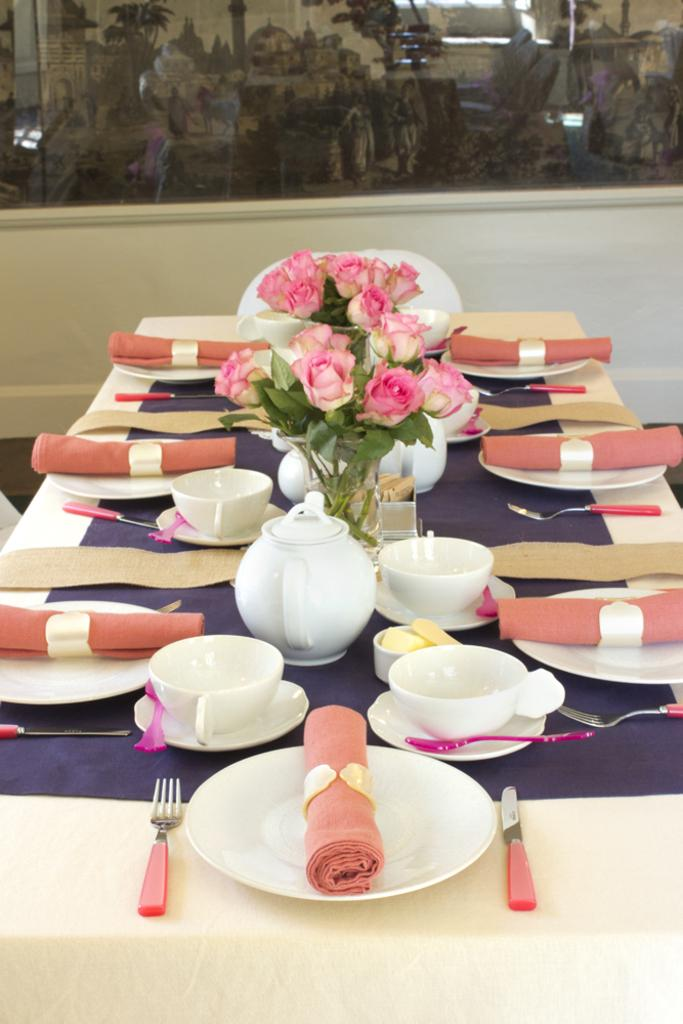What piece of furniture is present in the image? There is a table in the image. What is placed on the table? There is a plate, forks, a cup, a saucer, a bowl, a teapot, and a vase with flowers on the table. What is used to cover the plates? There is a cloth on the plates. What can be seen in the background of the image? There is a glass wall in the background of the image. How does the sack provide comfort to the person in the image? There is no sack present in the image, and therefore no comfort can be provided to a person. 